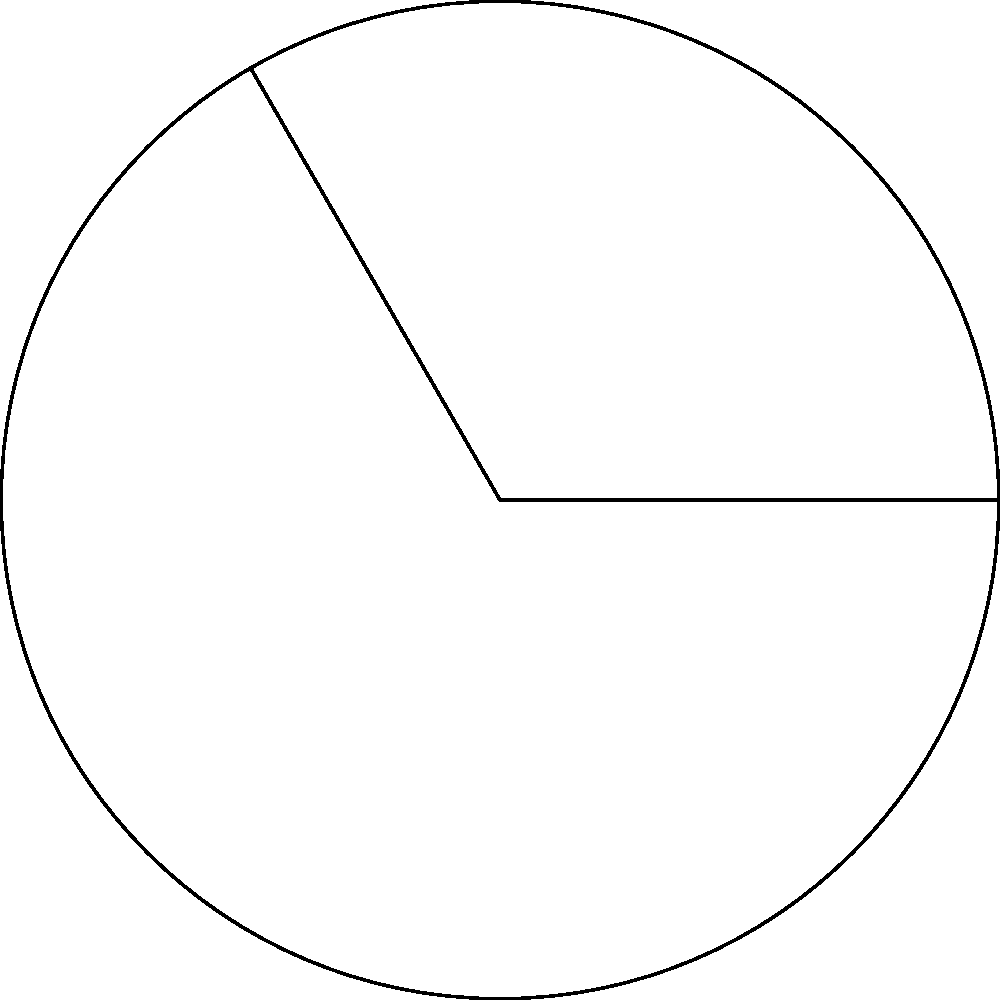In the circular sector shown above, the radius of the circle is 6 cm and the central angle $\theta$ is 120°. Calculate the area of the shaded sector, expressing your answer in terms of $\pi$ cm². How might this calculation relate to the concept of arc length in Mia Couto's novel "The Tuner of Silences," where circular patterns often symbolize the cycle of life and storytelling? To solve this problem, let's follow these steps:

1) First, recall the formula for the area of a circular sector:

   $$A = \frac{\theta}{360°} \cdot \pi r^2$$

   Where $A$ is the area, $\theta$ is the central angle in degrees, and $r$ is the radius.

2) We are given:
   - Radius $r = 6$ cm
   - Central angle $\theta = 120°$

3) Let's substitute these values into our formula:

   $$A = \frac{120°}{360°} \cdot \pi (6\text{ cm})^2$$

4) Simplify the fraction:

   $$A = \frac{1}{3} \cdot \pi \cdot 36\text{ cm}^2$$

5) Multiply:

   $$A = 12\pi\text{ cm}^2$$

This result connects to Mia Couto's "The Tuner of Silences" by representing a fraction of a full circle, much like how fragments of stories in the novel come together to form a complete narrative. The circular sector, occupying one-third of the full circle, could symbolize a partial perspective or an incomplete cycle in the storytelling process, reflecting the novel's exploration of memory, silence, and the cyclical nature of life.
Answer: $12\pi\text{ cm}^2$ 